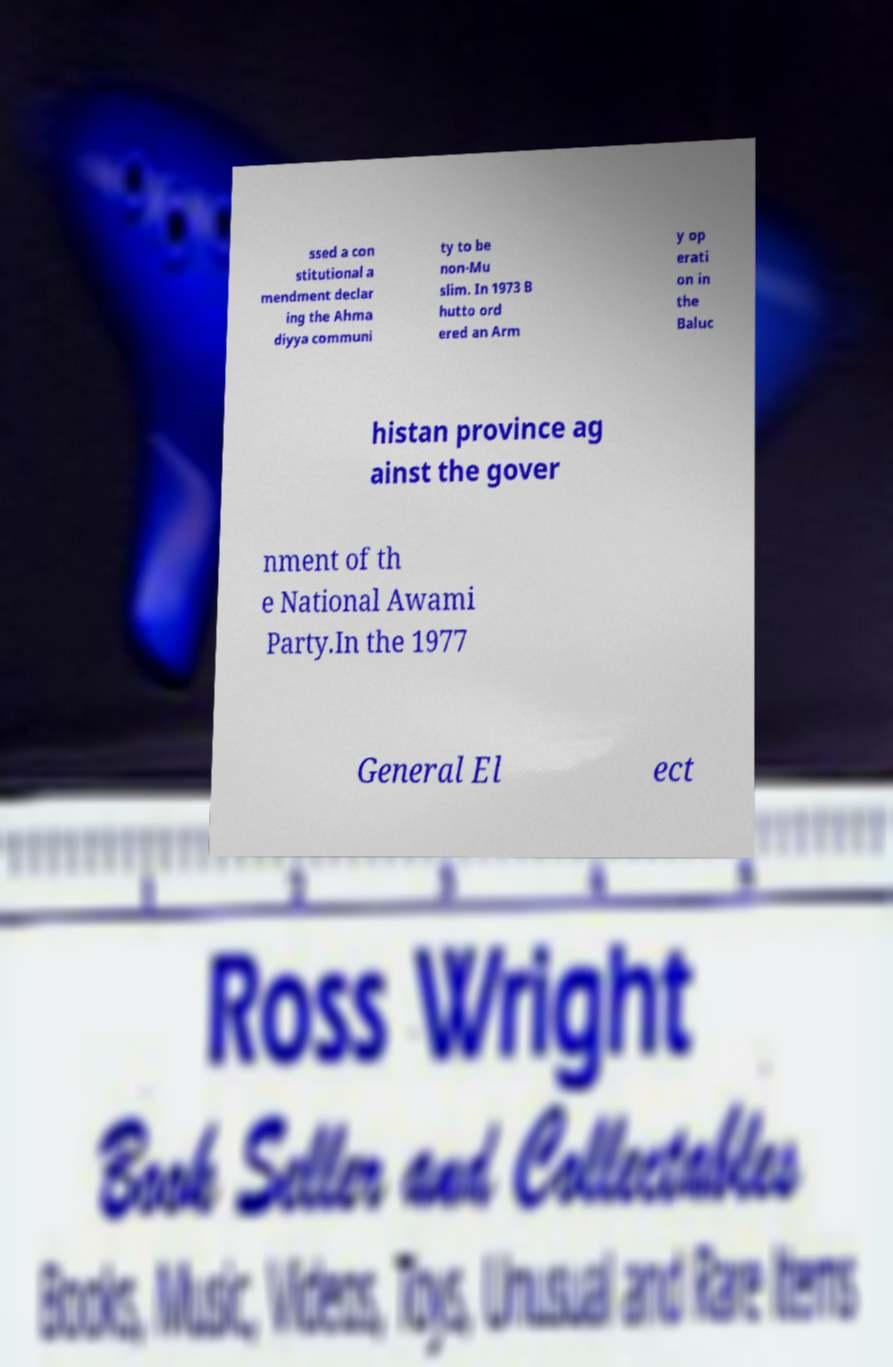I need the written content from this picture converted into text. Can you do that? ssed a con stitutional a mendment declar ing the Ahma diyya communi ty to be non-Mu slim. In 1973 B hutto ord ered an Arm y op erati on in the Baluc histan province ag ainst the gover nment of th e National Awami Party.In the 1977 General El ect 